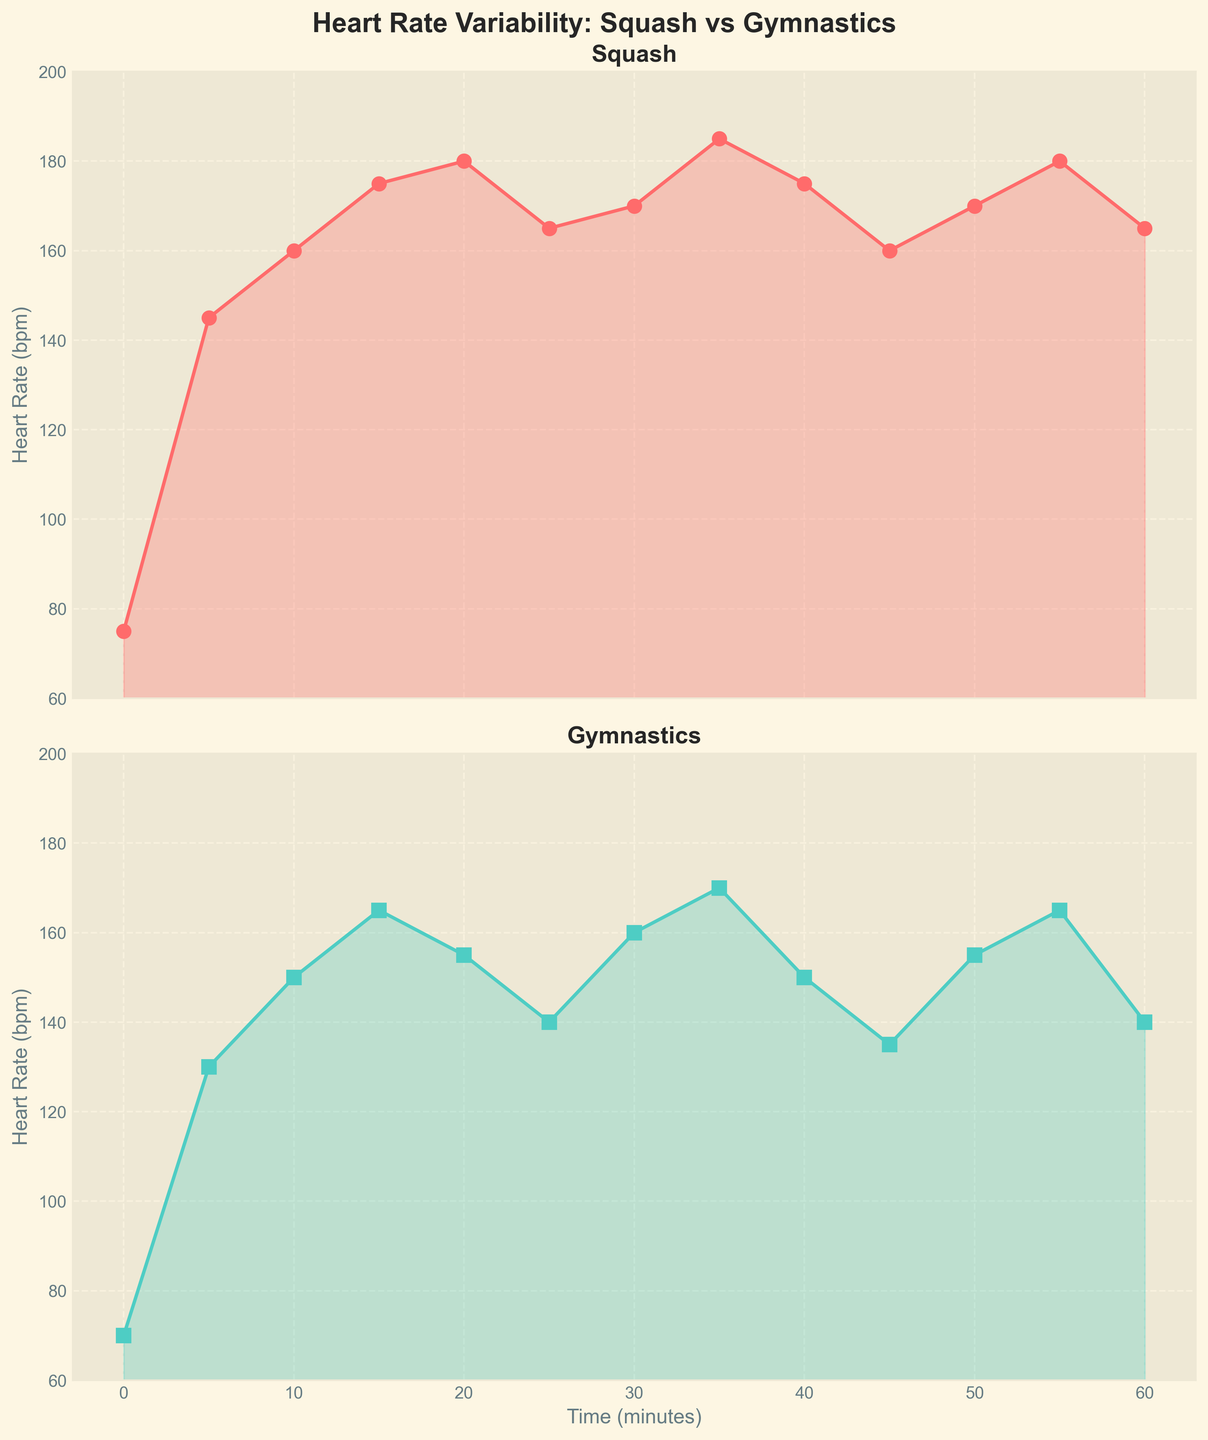What is the title of the figure? The title is written at the top of the figure. By directly looking at the central position at the top, we can read it.
Answer: Heart Rate Variability: Squash vs Gymnastics What are the colors of the lines representing squash and gymnastics heart rates? The lines for the squash and gymnastics heart rates are visually distinct in color. The squash line is shown in a reddish color, and the gymnastics line is shown in a greenish color.
Answer: Squash is red, and gymnastics is green What is the maximum heart rate recorded during the squash session? By looking at the highest point on the squash plot, which is in the first subplot, we can see that the maximum heart rate is at 185 bpm.
Answer: 185 bpm At which minute does the gymnastics heart rate drop to its lowest value? The lowest point on the gymnastics plot, found by looking at the second subplot, corresponds to the time at 45 minutes where the heart rate is 135 bpm.
Answer: 45 minutes What is the average heart rate for gymnastics over the entire session? To calculate the average heart rate for gymnastics, sum all the heart rate values and divide by the number of time points. The values are (70 + 130 + 150 + 165 + 155 + 140 + 160 + 170 + 150 + 135 + 155 + 165 + 140) = 1885 bpm. There are 13 time points, so the average is 1885/13 ≈ 145 bpm.
Answer: ~145 bpm Compare the heart rates at minute 30. Which activity has a higher rate, and by how much? Looking at the data at minute 30, the heart rate for squash is 170 bpm and for gymnastics is 160 bpm. The squash heart rate is higher by 10 bpm.
Answer: Squash is higher by 10 bpm What is the overall trend in heart rates for both activities from 0 to 60 minutes? By observing both plots, we can see that both activities generally increase in heart rate early on, maintain higher rates through the middle, and then show some decrease towards the end, though squash has more variability.
Answer: Increasing then decreasing How does the heart rate variability of squash compare to that of gymnastics over the whole session? By observing the variations in both plots, squash heart rates show higher peaks and more pronounced fluctuations compared to gymnastics heart rates which are more stable throughout the session.
Answer: Squash shows more variability In which segment (0-30 mins or 30-60 mins) is the squash heart rate more consistent? By examining the line smoothness in both segments of the squash plot, the 30-60 minutes segment shows less fluctuation and appears more consistent.
Answer: 30-60 mins 